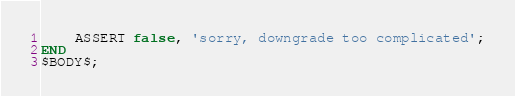Convert code to text. <code><loc_0><loc_0><loc_500><loc_500><_SQL_>	ASSERT false, 'sorry, downgrade too complicated';
END
$BODY$;
</code> 